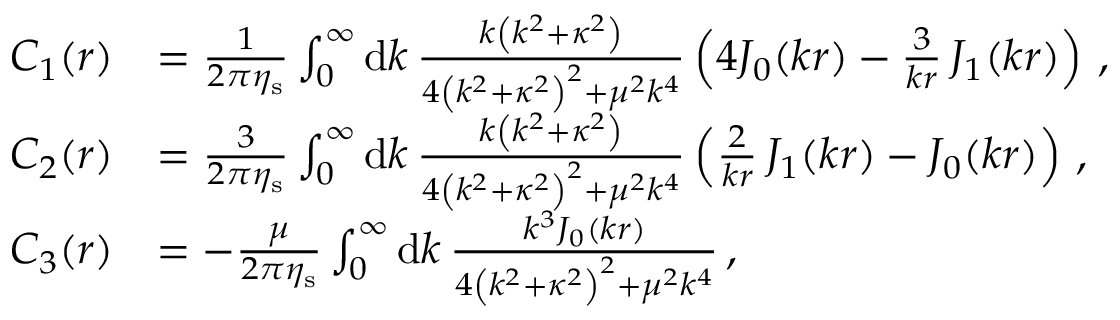<formula> <loc_0><loc_0><loc_500><loc_500>\begin{array} { r l } { C _ { 1 } ( r ) } & { = \frac { 1 } { 2 \pi \eta _ { s } } \int _ { 0 } ^ { \infty } d k \, \frac { k \left ( k ^ { 2 } + \kappa ^ { 2 } \right ) } { 4 \left ( k ^ { 2 } + \kappa ^ { 2 } \right ) ^ { 2 } + \mu ^ { 2 } k ^ { 4 } } \left ( 4 J _ { 0 } ( k r ) - \frac { 3 } { k r } \, J _ { 1 } ( k r ) \right ) \, , } \\ { C _ { 2 } ( r ) } & { = \frac { 3 } { 2 \pi \eta _ { s } } \int _ { 0 } ^ { \infty } d k \, \frac { k \left ( k ^ { 2 } + \kappa ^ { 2 } \right ) } { 4 \left ( k ^ { 2 } + \kappa ^ { 2 } \right ) ^ { 2 } + \mu ^ { 2 } k ^ { 4 } } \left ( \frac { 2 } { k r } \, J _ { 1 } ( k r ) - J _ { 0 } ( k r ) \right ) \, , } \\ { C _ { 3 } ( r ) } & { = - \frac { \mu } { 2 \pi \eta _ { s } } \int _ { 0 } ^ { \infty } d k \, \frac { k ^ { 3 } J _ { 0 } ( k r ) } { 4 \left ( k ^ { 2 } + \kappa ^ { 2 } \right ) ^ { 2 } + \mu ^ { 2 } k ^ { 4 } } \, , } \end{array}</formula> 